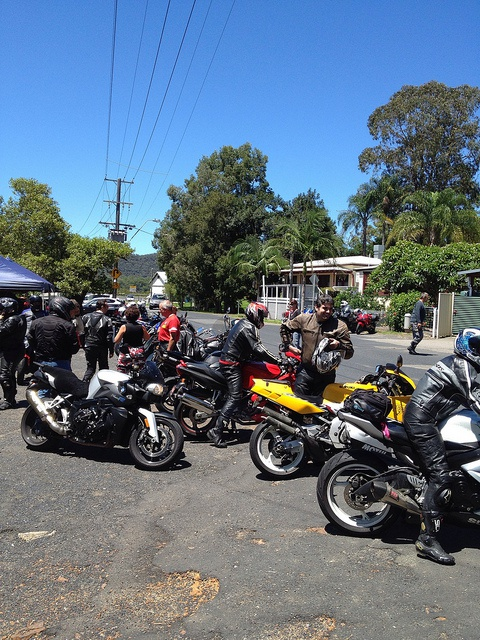Describe the objects in this image and their specific colors. I can see motorcycle in gray, black, white, and darkgray tones, motorcycle in gray, black, white, and darkgray tones, motorcycle in gray, black, darkgray, and gold tones, people in gray, black, and darkgray tones, and motorcycle in gray, black, maroon, and darkgray tones in this image. 